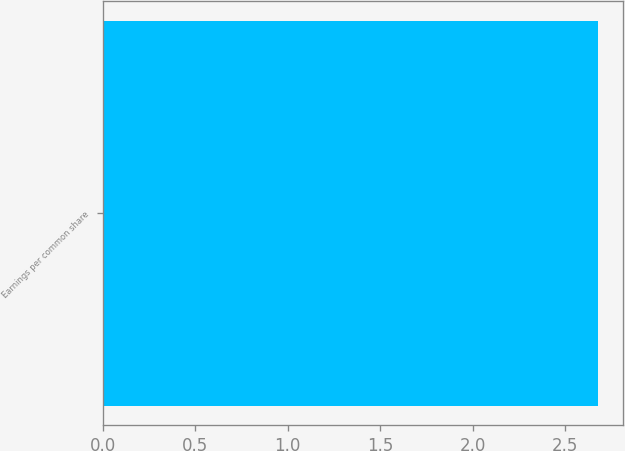<chart> <loc_0><loc_0><loc_500><loc_500><bar_chart><fcel>Earnings per common share<nl><fcel>2.68<nl></chart> 